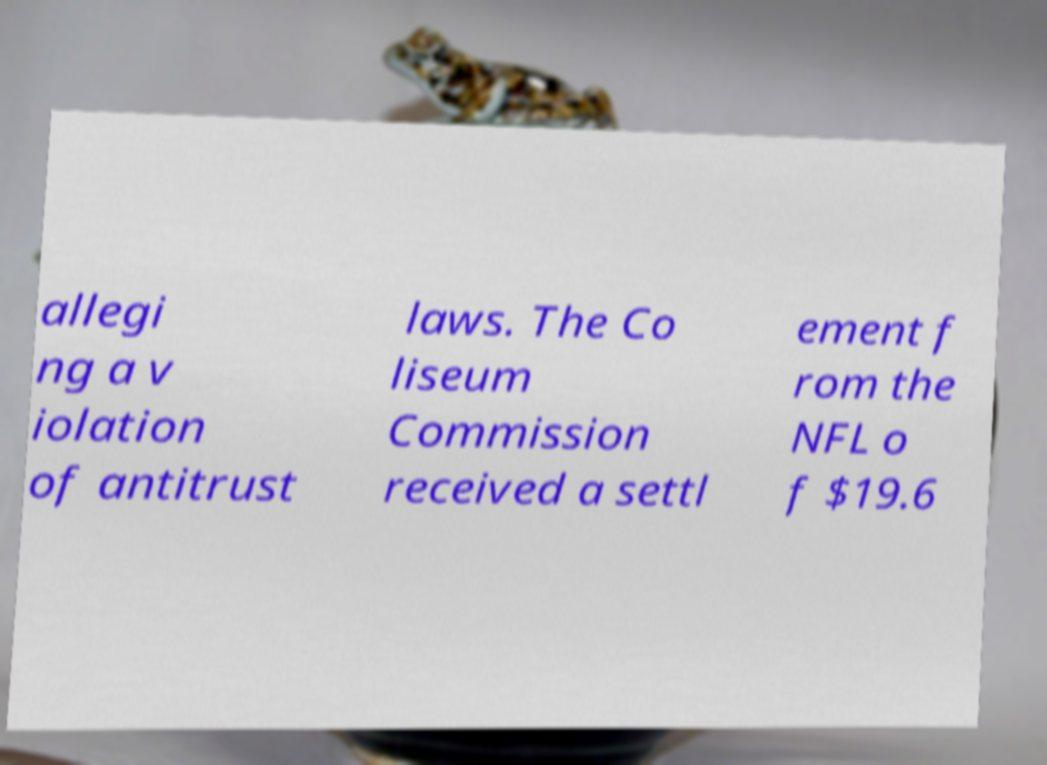For documentation purposes, I need the text within this image transcribed. Could you provide that? allegi ng a v iolation of antitrust laws. The Co liseum Commission received a settl ement f rom the NFL o f $19.6 